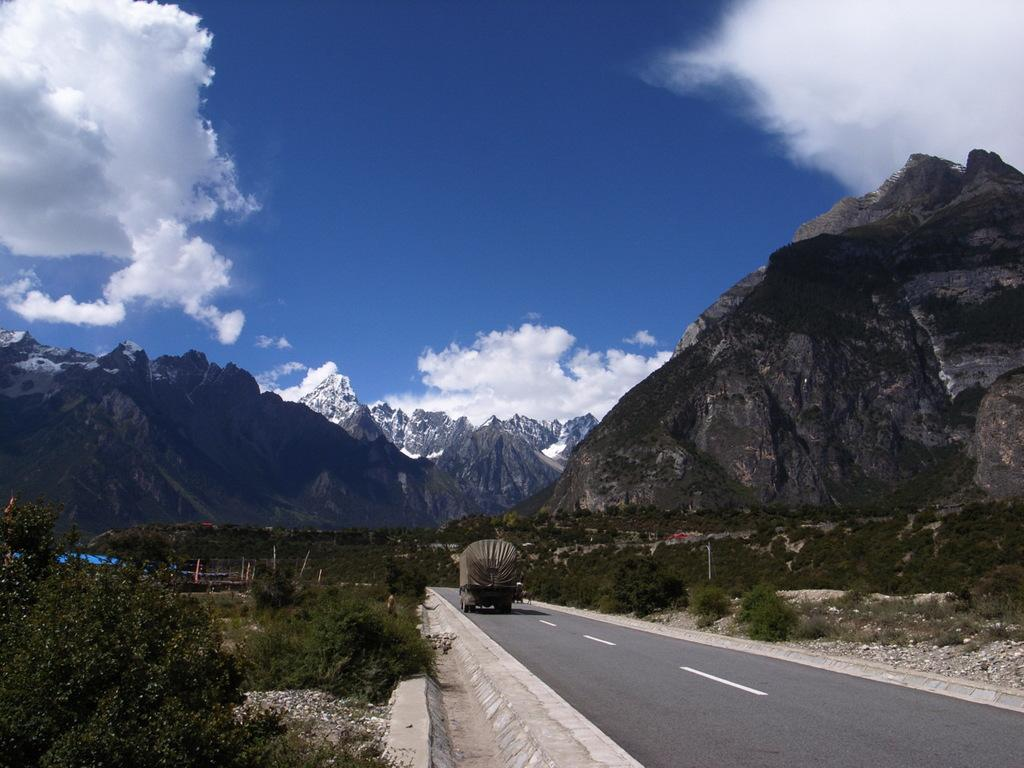What type of motor vehicle can be seen on the road in the image? The image does not specify the type of motor vehicle, but there is a motor vehicle on the road. What type of vegetation is present in the image? There are bushes, trees, and tents in the image. What type of natural features can be seen in the image? There are hills, mountains, and stones in the image. What is visible in the sky in the image? The sky is visible in the image, and there are clouds present. What word is being taught in the image? There is no indication of any teaching or learning activity in the image. Can you provide an example of the teaching method used in the image? There is no teaching or learning activity in the image, so it is not possible to provide an example of the teaching method. 